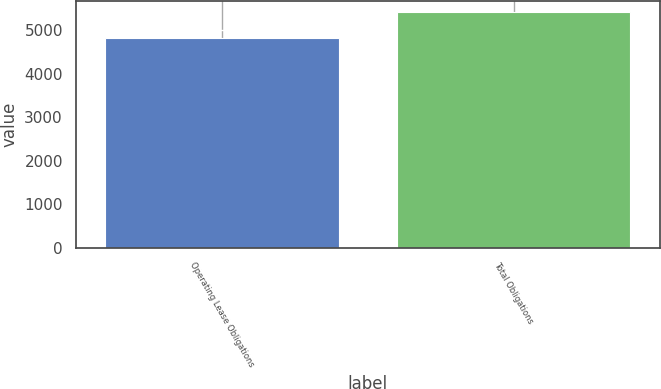Convert chart. <chart><loc_0><loc_0><loc_500><loc_500><bar_chart><fcel>Operating Lease Obligations<fcel>Total Obligations<nl><fcel>4819<fcel>5419<nl></chart> 